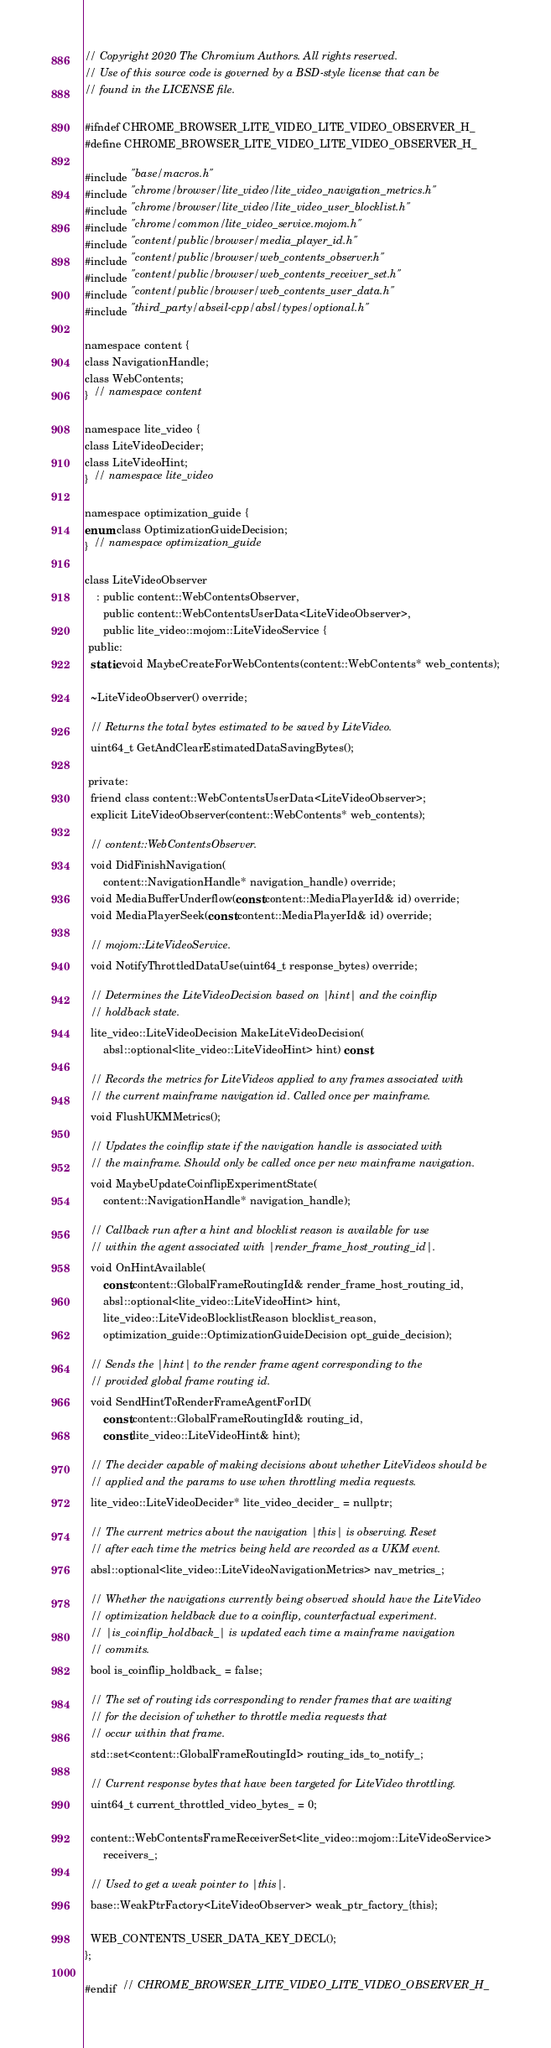<code> <loc_0><loc_0><loc_500><loc_500><_C_>// Copyright 2020 The Chromium Authors. All rights reserved.
// Use of this source code is governed by a BSD-style license that can be
// found in the LICENSE file.

#ifndef CHROME_BROWSER_LITE_VIDEO_LITE_VIDEO_OBSERVER_H_
#define CHROME_BROWSER_LITE_VIDEO_LITE_VIDEO_OBSERVER_H_

#include "base/macros.h"
#include "chrome/browser/lite_video/lite_video_navigation_metrics.h"
#include "chrome/browser/lite_video/lite_video_user_blocklist.h"
#include "chrome/common/lite_video_service.mojom.h"
#include "content/public/browser/media_player_id.h"
#include "content/public/browser/web_contents_observer.h"
#include "content/public/browser/web_contents_receiver_set.h"
#include "content/public/browser/web_contents_user_data.h"
#include "third_party/abseil-cpp/absl/types/optional.h"

namespace content {
class NavigationHandle;
class WebContents;
}  // namespace content

namespace lite_video {
class LiteVideoDecider;
class LiteVideoHint;
}  // namespace lite_video

namespace optimization_guide {
enum class OptimizationGuideDecision;
}  // namespace optimization_guide

class LiteVideoObserver
    : public content::WebContentsObserver,
      public content::WebContentsUserData<LiteVideoObserver>,
      public lite_video::mojom::LiteVideoService {
 public:
  static void MaybeCreateForWebContents(content::WebContents* web_contents);

  ~LiteVideoObserver() override;

  // Returns the total bytes estimated to be saved by LiteVideo.
  uint64_t GetAndClearEstimatedDataSavingBytes();

 private:
  friend class content::WebContentsUserData<LiteVideoObserver>;
  explicit LiteVideoObserver(content::WebContents* web_contents);

  // content::WebContentsObserver.
  void DidFinishNavigation(
      content::NavigationHandle* navigation_handle) override;
  void MediaBufferUnderflow(const content::MediaPlayerId& id) override;
  void MediaPlayerSeek(const content::MediaPlayerId& id) override;

  // mojom::LiteVideoService.
  void NotifyThrottledDataUse(uint64_t response_bytes) override;

  // Determines the LiteVideoDecision based on |hint| and the coinflip
  // holdback state.
  lite_video::LiteVideoDecision MakeLiteVideoDecision(
      absl::optional<lite_video::LiteVideoHint> hint) const;

  // Records the metrics for LiteVideos applied to any frames associated with
  // the current mainframe navigation id. Called once per mainframe.
  void FlushUKMMetrics();

  // Updates the coinflip state if the navigation handle is associated with
  // the mainframe. Should only be called once per new mainframe navigation.
  void MaybeUpdateCoinflipExperimentState(
      content::NavigationHandle* navigation_handle);

  // Callback run after a hint and blocklist reason is available for use
  // within the agent associated with |render_frame_host_routing_id|.
  void OnHintAvailable(
      const content::GlobalFrameRoutingId& render_frame_host_routing_id,
      absl::optional<lite_video::LiteVideoHint> hint,
      lite_video::LiteVideoBlocklistReason blocklist_reason,
      optimization_guide::OptimizationGuideDecision opt_guide_decision);

  // Sends the |hint| to the render frame agent corresponding to the
  // provided global frame routing id.
  void SendHintToRenderFrameAgentForID(
      const content::GlobalFrameRoutingId& routing_id,
      const lite_video::LiteVideoHint& hint);

  // The decider capable of making decisions about whether LiteVideos should be
  // applied and the params to use when throttling media requests.
  lite_video::LiteVideoDecider* lite_video_decider_ = nullptr;

  // The current metrics about the navigation |this| is observing. Reset
  // after each time the metrics being held are recorded as a UKM event.
  absl::optional<lite_video::LiteVideoNavigationMetrics> nav_metrics_;

  // Whether the navigations currently being observed should have the LiteVideo
  // optimization heldback due to a coinflip, counterfactual experiment.
  // |is_coinflip_holdback_| is updated each time a mainframe navigation
  // commits.
  bool is_coinflip_holdback_ = false;

  // The set of routing ids corresponding to render frames that are waiting
  // for the decision of whether to throttle media requests that
  // occur within that frame.
  std::set<content::GlobalFrameRoutingId> routing_ids_to_notify_;

  // Current response bytes that have been targeted for LiteVideo throttling.
  uint64_t current_throttled_video_bytes_ = 0;

  content::WebContentsFrameReceiverSet<lite_video::mojom::LiteVideoService>
      receivers_;

  // Used to get a weak pointer to |this|.
  base::WeakPtrFactory<LiteVideoObserver> weak_ptr_factory_{this};

  WEB_CONTENTS_USER_DATA_KEY_DECL();
};

#endif  // CHROME_BROWSER_LITE_VIDEO_LITE_VIDEO_OBSERVER_H_
</code> 